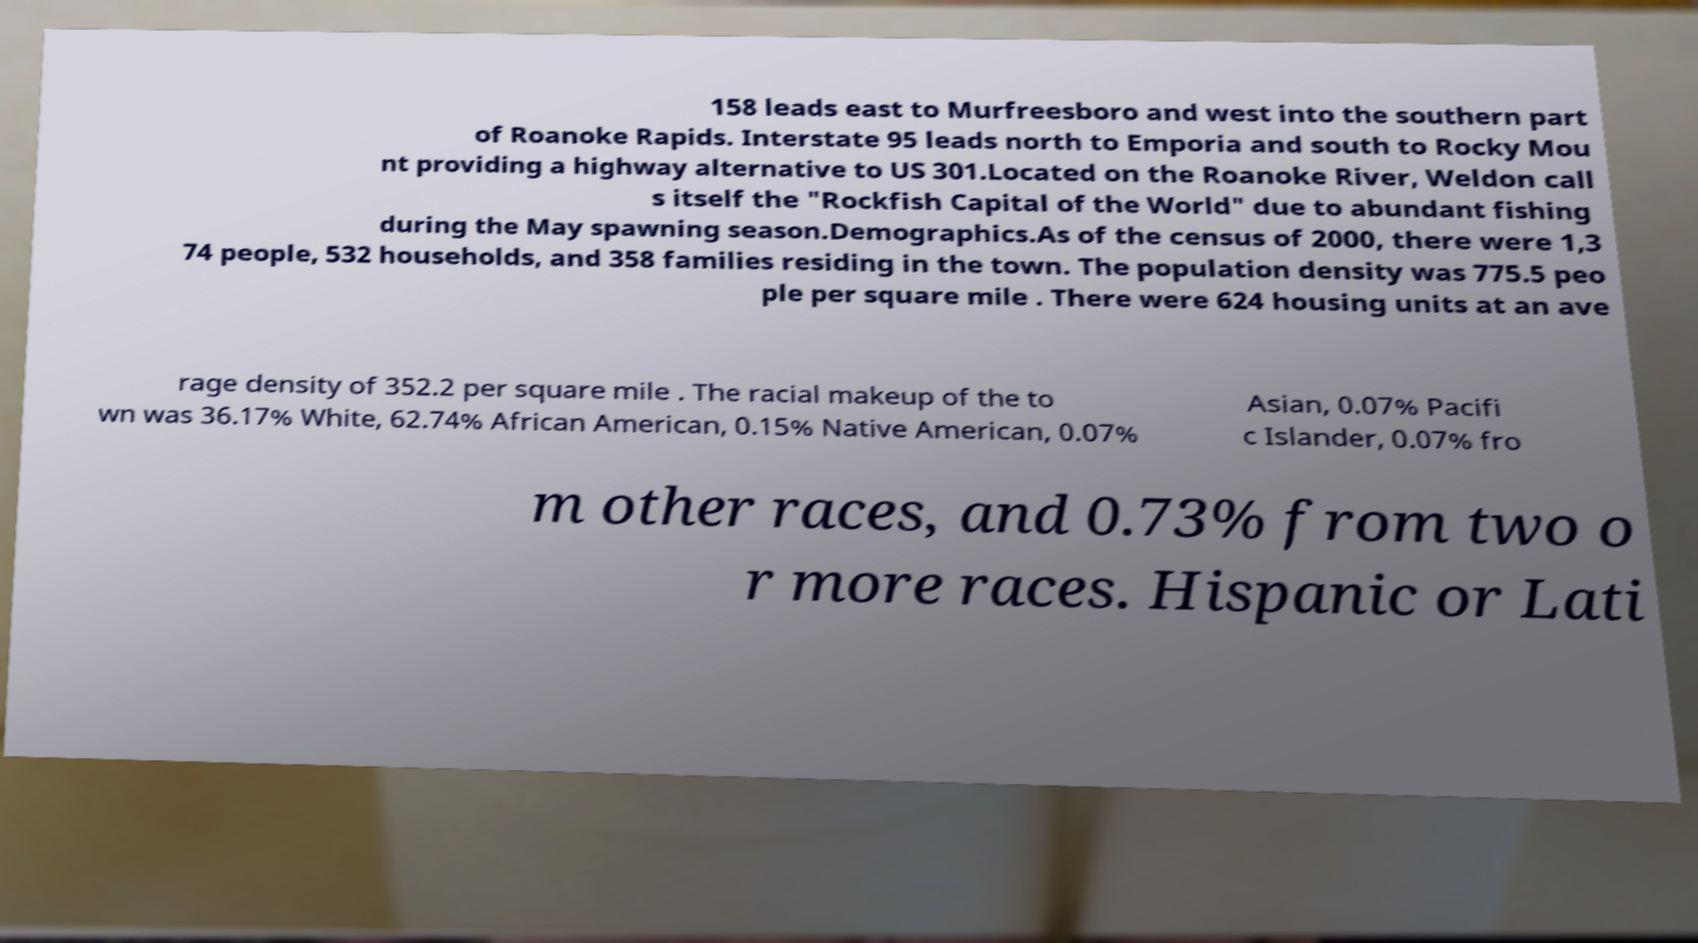Could you extract and type out the text from this image? 158 leads east to Murfreesboro and west into the southern part of Roanoke Rapids. Interstate 95 leads north to Emporia and south to Rocky Mou nt providing a highway alternative to US 301.Located on the Roanoke River, Weldon call s itself the "Rockfish Capital of the World" due to abundant fishing during the May spawning season.Demographics.As of the census of 2000, there were 1,3 74 people, 532 households, and 358 families residing in the town. The population density was 775.5 peo ple per square mile . There were 624 housing units at an ave rage density of 352.2 per square mile . The racial makeup of the to wn was 36.17% White, 62.74% African American, 0.15% Native American, 0.07% Asian, 0.07% Pacifi c Islander, 0.07% fro m other races, and 0.73% from two o r more races. Hispanic or Lati 